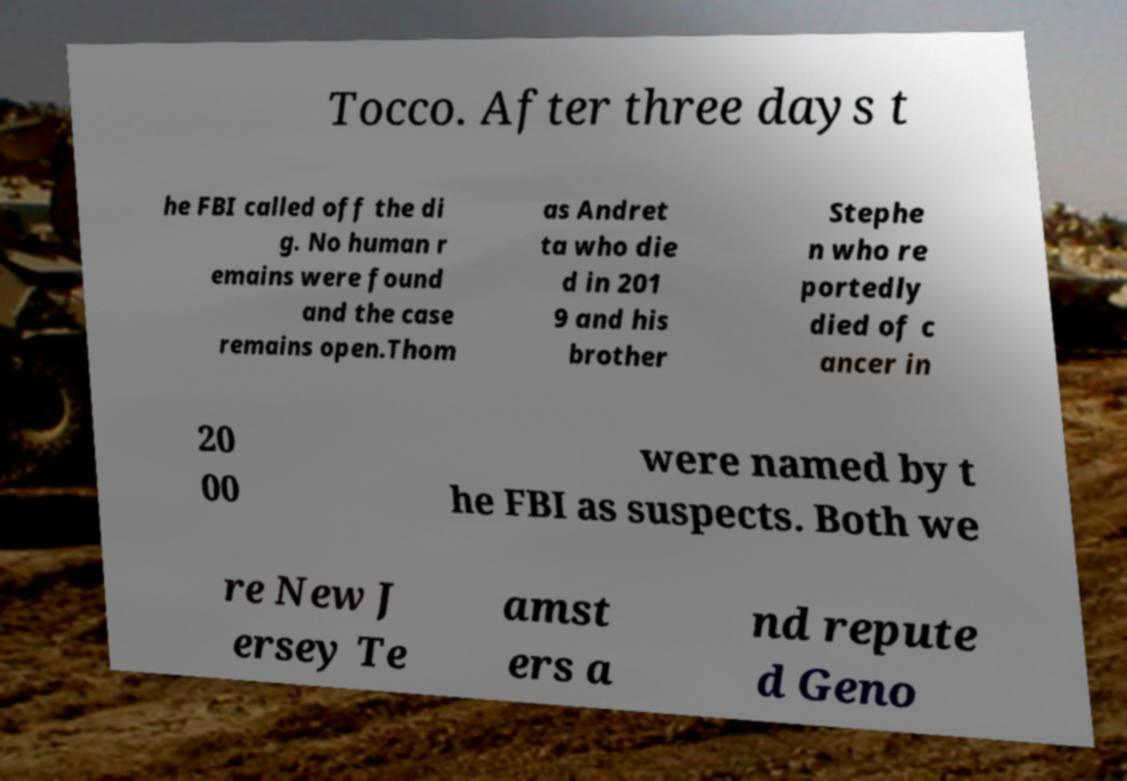For documentation purposes, I need the text within this image transcribed. Could you provide that? Tocco. After three days t he FBI called off the di g. No human r emains were found and the case remains open.Thom as Andret ta who die d in 201 9 and his brother Stephe n who re portedly died of c ancer in 20 00 were named by t he FBI as suspects. Both we re New J ersey Te amst ers a nd repute d Geno 